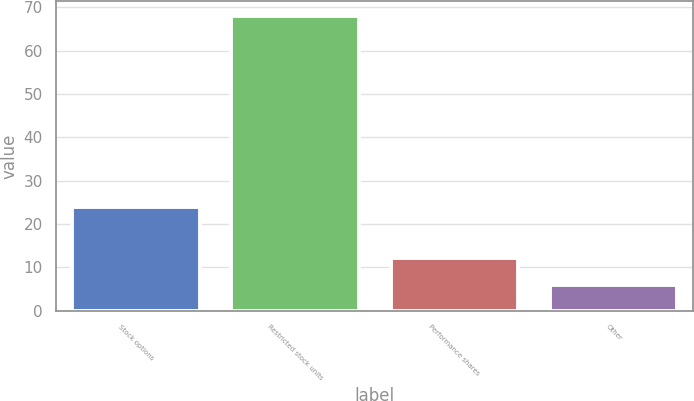<chart> <loc_0><loc_0><loc_500><loc_500><bar_chart><fcel>Stock options<fcel>Restricted stock units<fcel>Performance shares<fcel>Other<nl><fcel>24<fcel>68<fcel>12.2<fcel>6<nl></chart> 